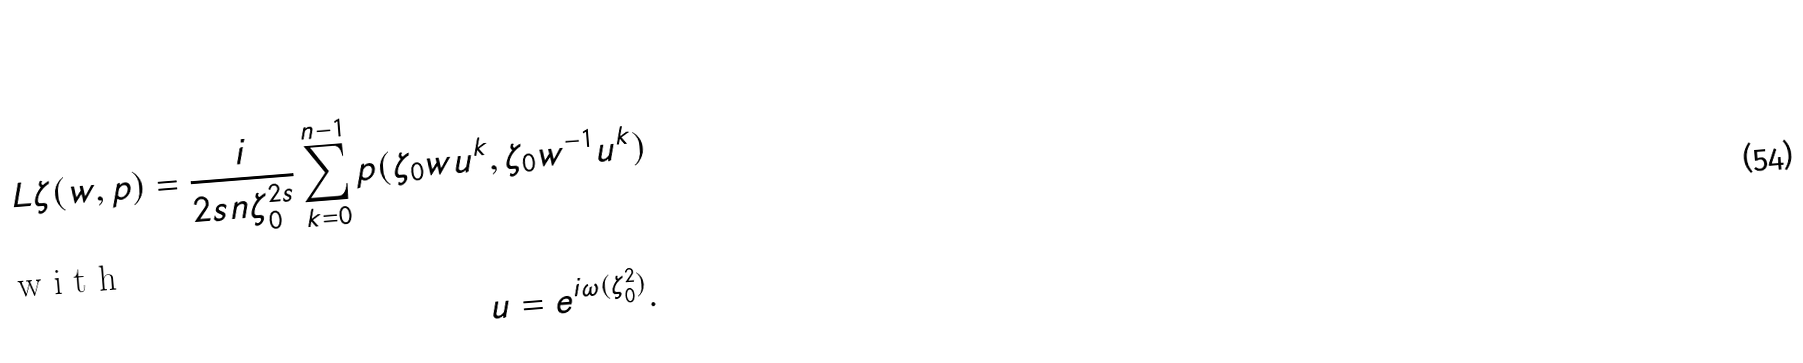Convert formula to latex. <formula><loc_0><loc_0><loc_500><loc_500>L \zeta ( w , p ) = \frac { i } { 2 s n \zeta _ { 0 } ^ { 2 s } } \sum _ { k = 0 } ^ { n - 1 } p ( \zeta _ { 0 } w u ^ { k } , \zeta _ { 0 } w ^ { - 1 } u ^ { k } ) \\ \intertext { w i t h } u = e ^ { i \omega ( \zeta _ { 0 } ^ { 2 } ) } .</formula> 